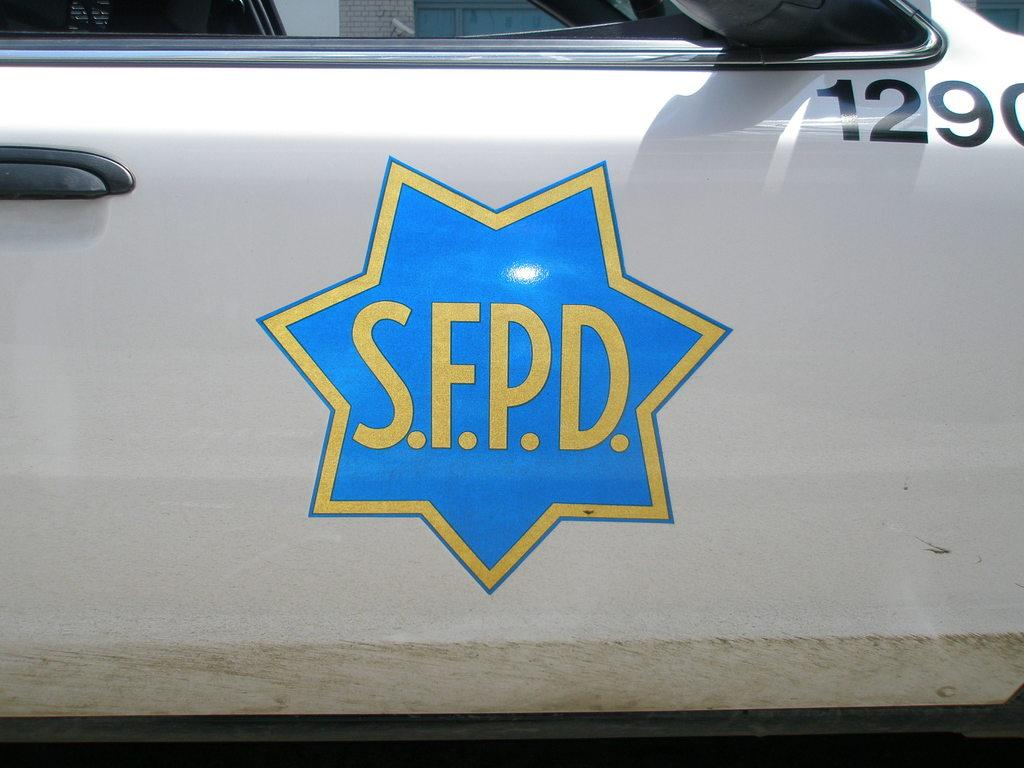What is the main subject of the image? The main subject of the image is a vehicle. Can you describe any specific features of the vehicle? Yes, there is a logo on the vehicle. How does the vehicle help people with knee problems in the image? The image does not show the vehicle helping people with knee problems, nor does it provide any information about the vehicle's purpose or capabilities. 